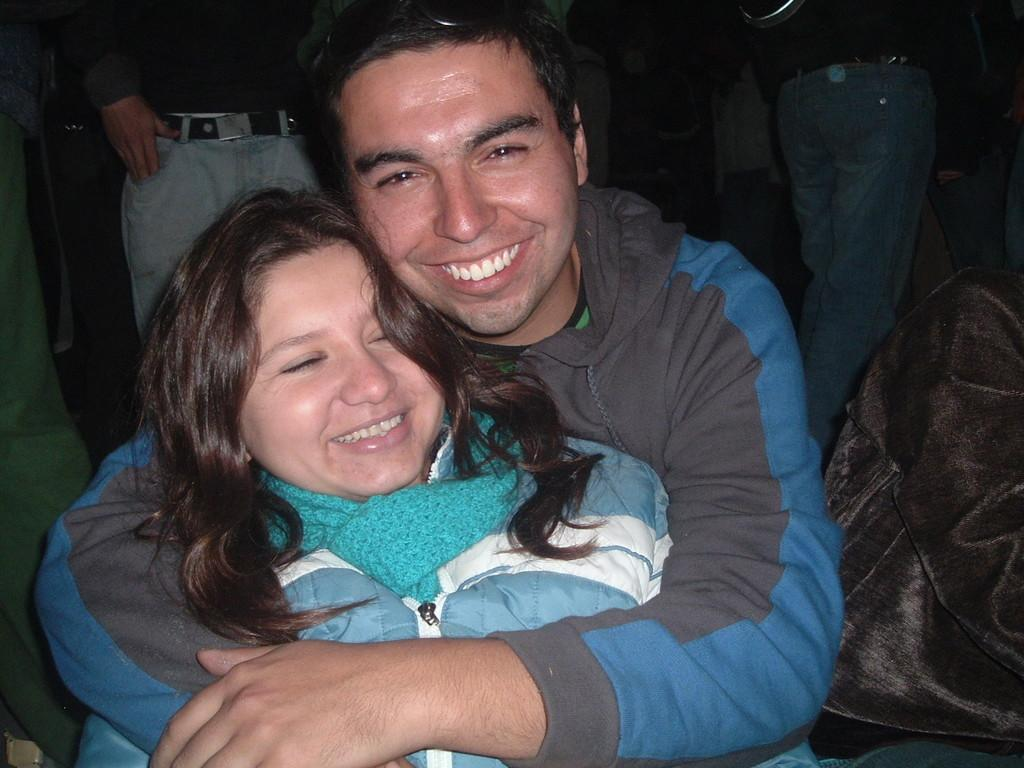Who can be seen in the foreground of the image? There is a man and a woman in the foreground of the image. What expressions do the man and woman have? Both the man and the woman are smiling. Can you describe the person standing beside the man and woman? There is another person standing beside the man and woman. What can be seen in the background of the image? There are some people standing in the background of the image. What type of spots can be seen on the calendar in the image? There is no calendar present in the image, so no spots can be observed. How many arms does the man have in the image? The man in the image has two arms, as is typical for humans. 